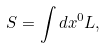<formula> <loc_0><loc_0><loc_500><loc_500>S = \int d x ^ { 0 } L ,</formula> 